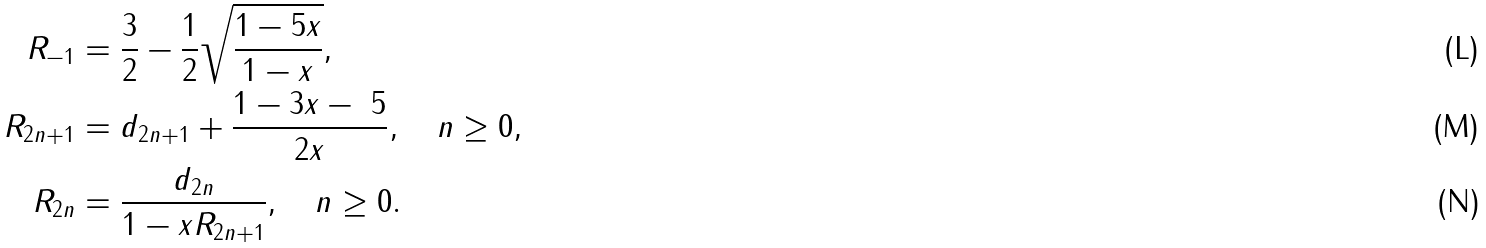Convert formula to latex. <formula><loc_0><loc_0><loc_500><loc_500>R _ { - 1 } & = \frac { 3 } { 2 } - \frac { 1 } { 2 } \sqrt { \frac { 1 - 5 x } { 1 - x } } , \\ R _ { 2 n + 1 } & = d _ { 2 n + 1 } + \frac { 1 - 3 x - \ 5 } { 2 x } , \quad n \geq 0 , \\ R _ { 2 n } & = \frac { d _ { 2 n } } { 1 - x R _ { 2 n + 1 } } , \quad n \geq 0 .</formula> 